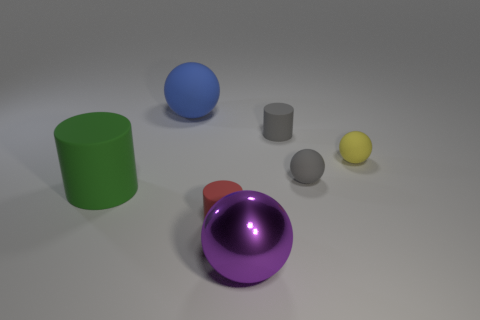Can you tell me which objects are reflective? Sure, the purple sphere in the foreground has a high level of reflectivity, indicating a polished or glossy material. Likewise, the blue sphere and the green cylinder also have reflective surfaces, albeit with slightly less intensity. 